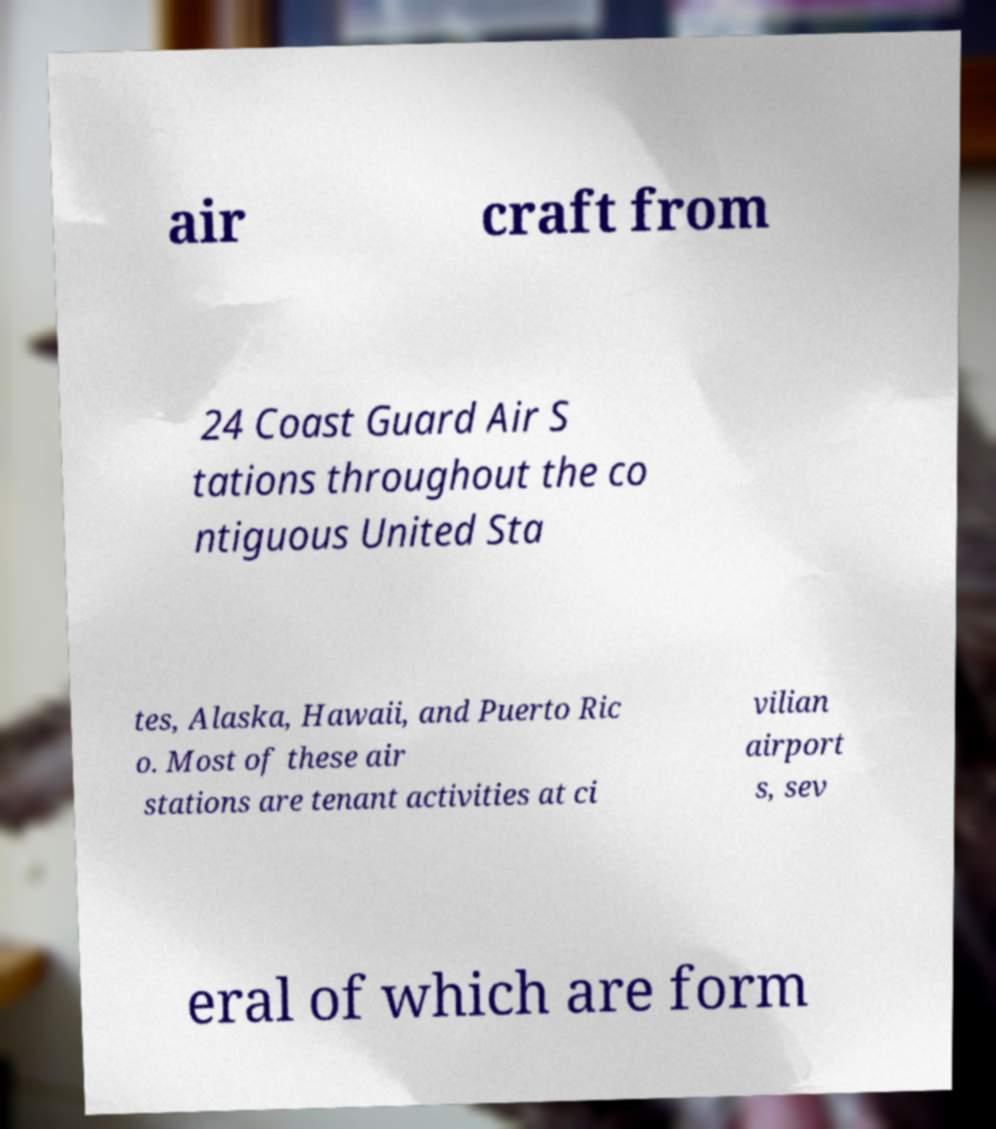Could you extract and type out the text from this image? air craft from 24 Coast Guard Air S tations throughout the co ntiguous United Sta tes, Alaska, Hawaii, and Puerto Ric o. Most of these air stations are tenant activities at ci vilian airport s, sev eral of which are form 